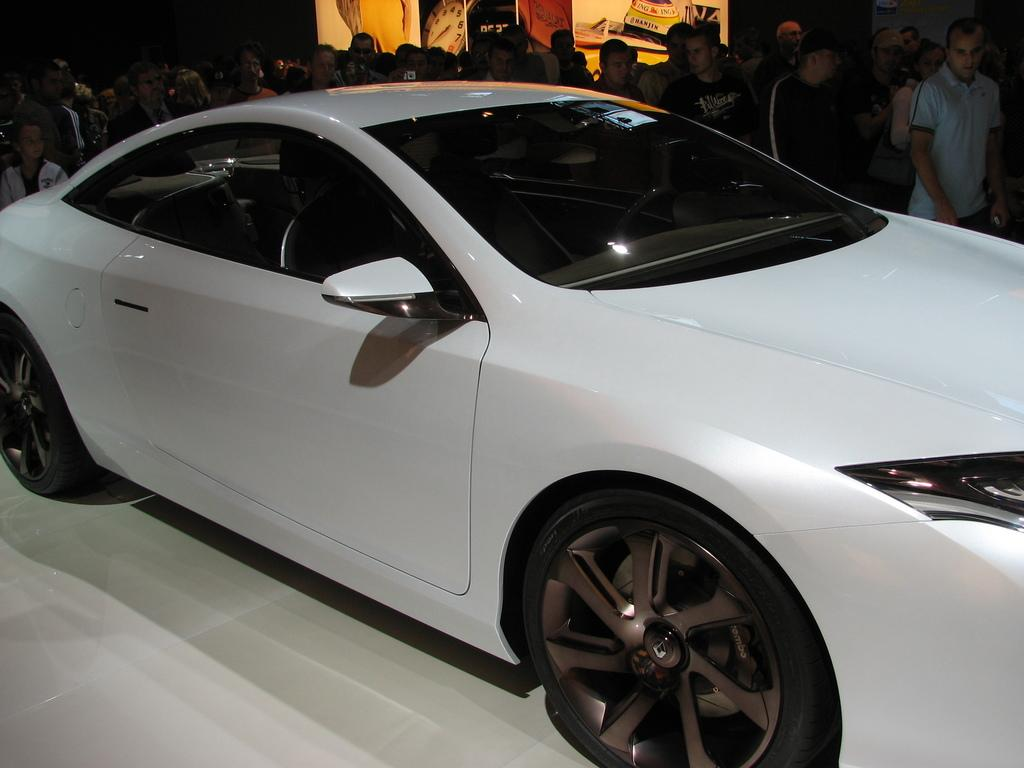What type of vehicle is in the front of the image? There is a white color car in the front of the image. What can be seen in the background of the image? There are people standing in the background of the image, and there appears to be a hoarding. How many minutes does it take for the car to attack the people in the image? There is no attack or time-related action in the image; it simply shows a car in the front and people standing in the background. 